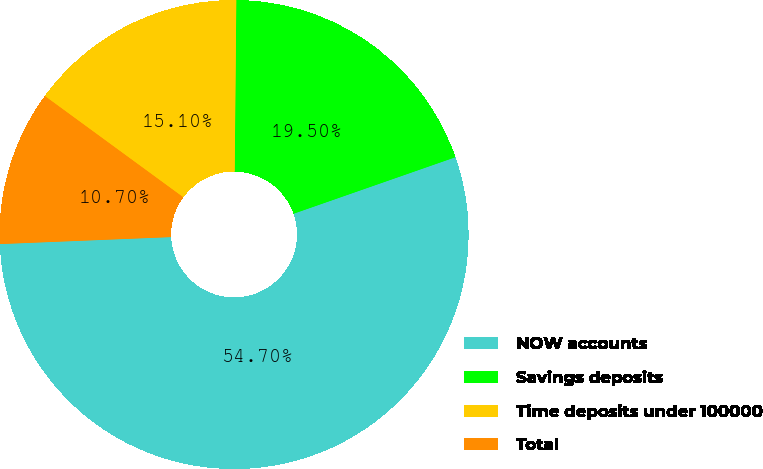Convert chart to OTSL. <chart><loc_0><loc_0><loc_500><loc_500><pie_chart><fcel>NOW accounts<fcel>Savings deposits<fcel>Time deposits under 100000<fcel>Total<nl><fcel>54.7%<fcel>19.5%<fcel>15.1%<fcel>10.7%<nl></chart> 